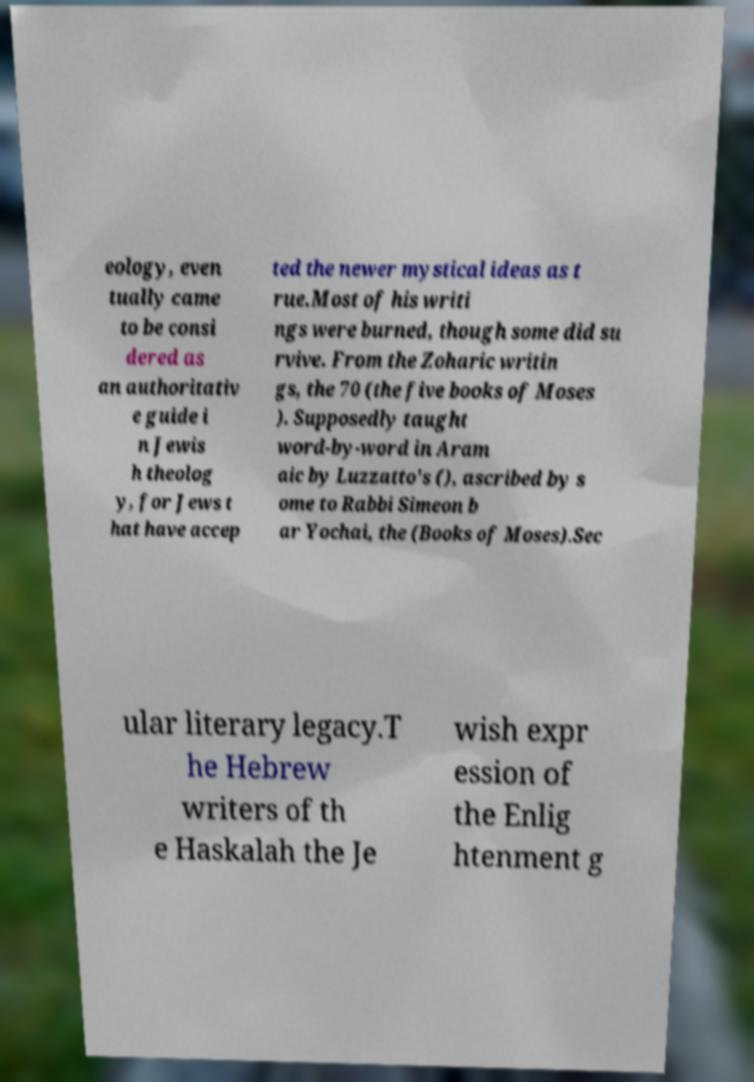Could you extract and type out the text from this image? eology, even tually came to be consi dered as an authoritativ e guide i n Jewis h theolog y, for Jews t hat have accep ted the newer mystical ideas as t rue.Most of his writi ngs were burned, though some did su rvive. From the Zoharic writin gs, the 70 (the five books of Moses ). Supposedly taught word-by-word in Aram aic by Luzzatto's (), ascribed by s ome to Rabbi Simeon b ar Yochai, the (Books of Moses).Sec ular literary legacy.T he Hebrew writers of th e Haskalah the Je wish expr ession of the Enlig htenment g 